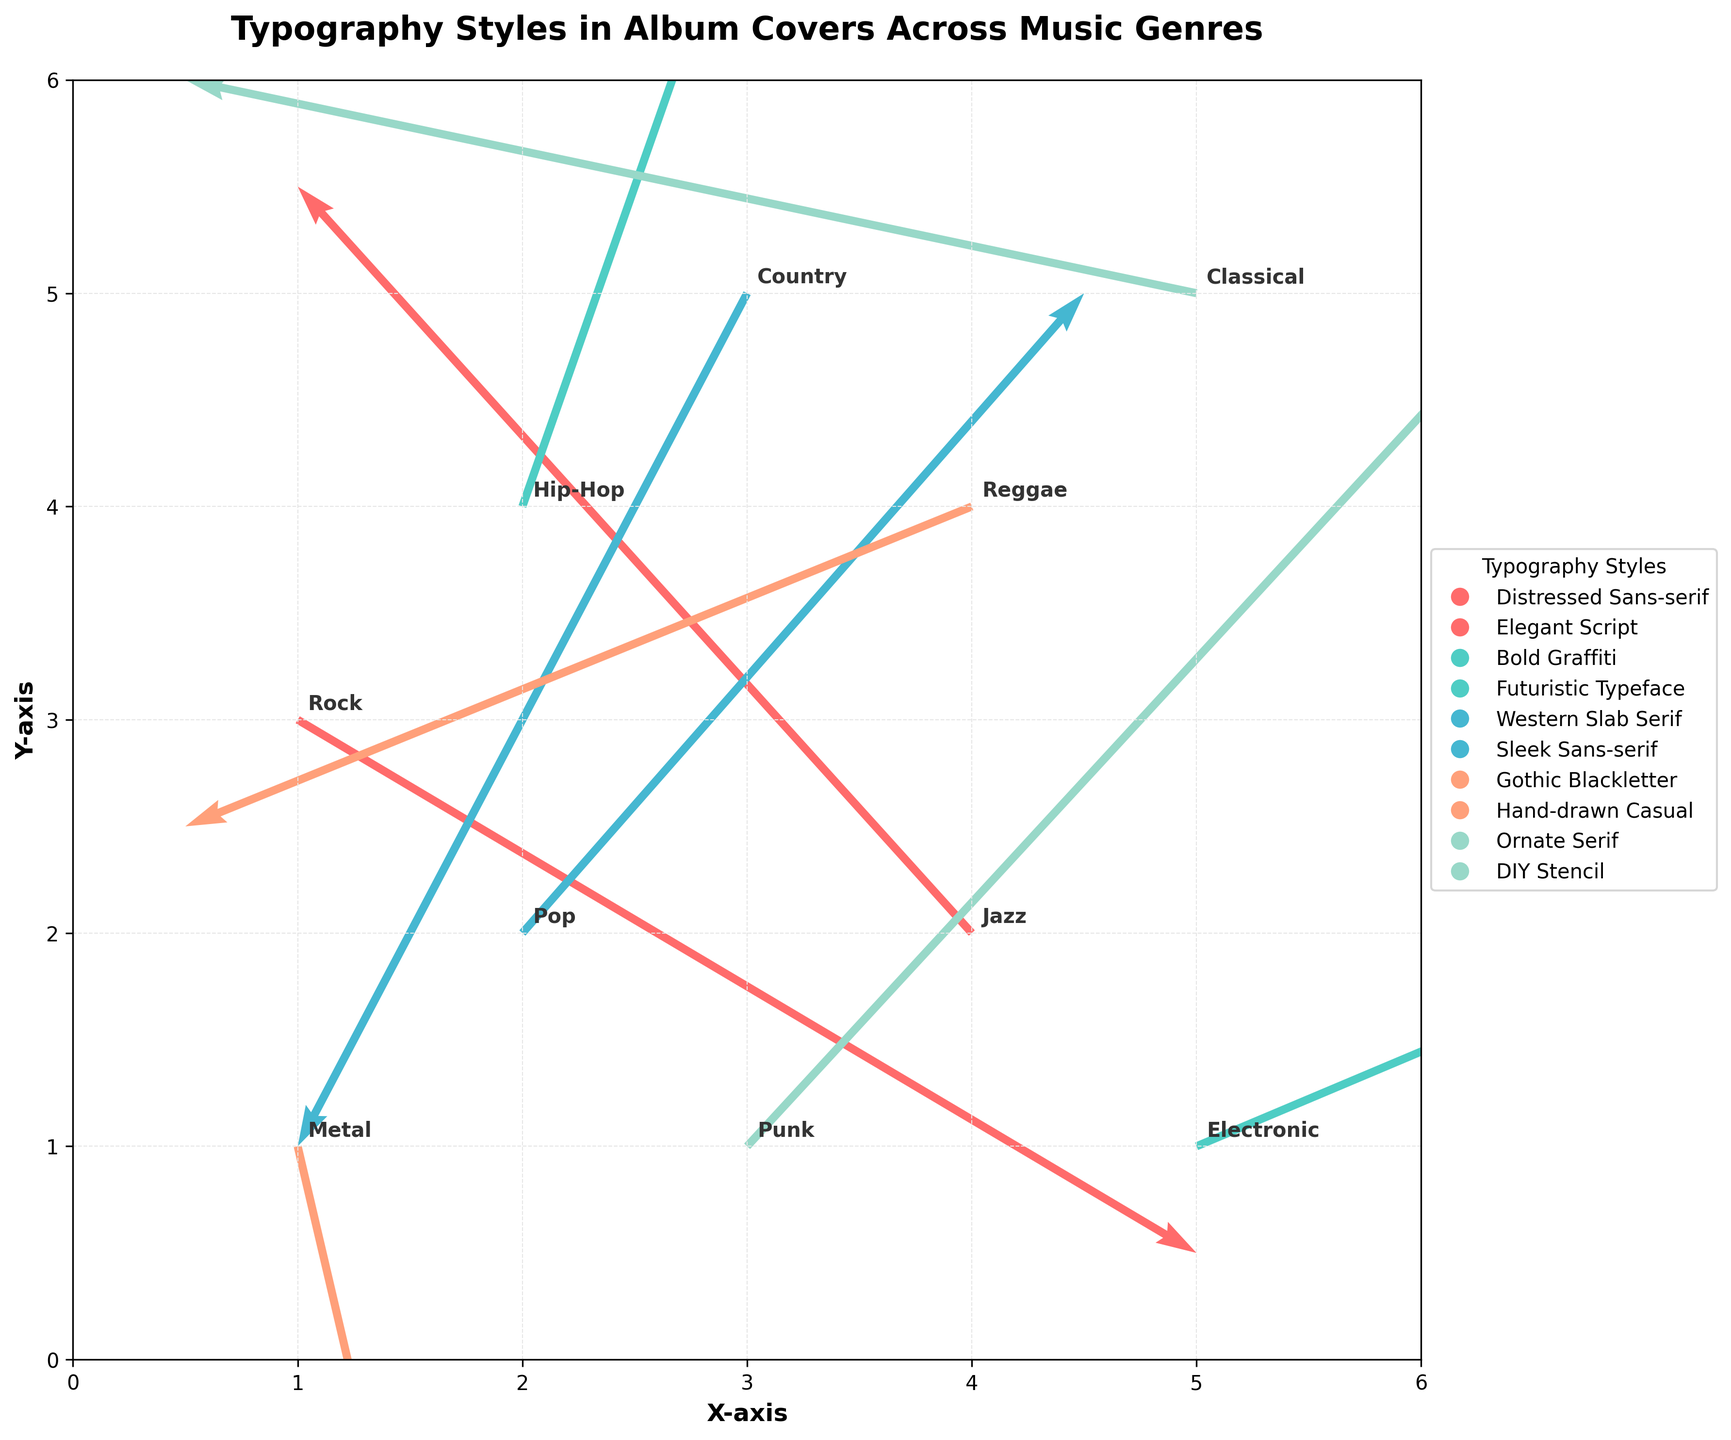How many genres are represented in the figure? Count the number of unique genre labels on the plot. There are 10 unique genre labels visible.
Answer: 10 What direction does the typography style "Futuristic Typeface" point to on the plot? Locate the "Electronic" genre label (which uses "Futuristic Typeface") and observe the direction of the arrow originating from it. The arrow points to the right and slightly upwards.
Answer: Right and slightly upwards Which genre has an arrow pointing most directly upwards? Look for the arrow that is most vertical and pointing upwards. The arrow starting from “Hip-Hop” at (2, 4) points most directly upwards.
Answer: Hip-Hop Which typography style is associated with the genre located at (5, 5)? Find the arrow starting from the coordinates (5, 5) and check the associated label. The genre is "Classical" and the typography style is "Ornate Serif".
Answer: Ornate Serif Which genre has a typography style that trends most downward? Identify the arrow with the most significant downward component. The genre “Metal” at (1, 1) has a typography style "Gothic Blackletter" pointing most downward.
Answer: Metal Which genres use typography styles that trend towards the left side of the plot? Determine arrows with x-components moving left (negative u values). The genres "Jazz" (4, 2), "Country" (3, 5), and "Classical" (5, 5) trend towards the left.
Answer: Jazz, Country, Classical What is the range of x-coordinates and y-coordinates used in the figure? Observe the axes limits and the data points' coordinates. The x-coordinates and y-coordinates range from 0 to 6.
Answer: 0 to 6 Which genre has the closest horizontal component to zero? Identify the arrow closest to a purely vertical direction. The genre "Metal" (1, 1) with u = 0.2 has the closest horizontal component to zero.
Answer: Metal Which genres have typography styles with both positive components (u and v)? Check arrows with both u and v components positive. The genres "Hip-Hop" (2, 4), "Pop" (2, 2), and "Electronic" (5, 1) fit this criterion.
Answer: Hip-Hop, Pop, Electronic 